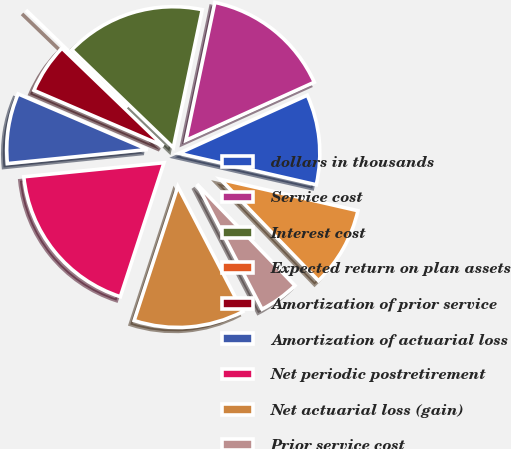<chart> <loc_0><loc_0><loc_500><loc_500><pie_chart><fcel>dollars in thousands<fcel>Service cost<fcel>Interest cost<fcel>Expected return on plan assets<fcel>Amortization of prior service<fcel>Amortization of actuarial loss<fcel>Net periodic postretirement<fcel>Net actuarial loss (gain)<fcel>Prior service cost<fcel>Reclassification of actuarial<nl><fcel>10.34%<fcel>14.94%<fcel>16.09%<fcel>0.0%<fcel>5.75%<fcel>8.05%<fcel>18.39%<fcel>12.64%<fcel>4.6%<fcel>9.2%<nl></chart> 